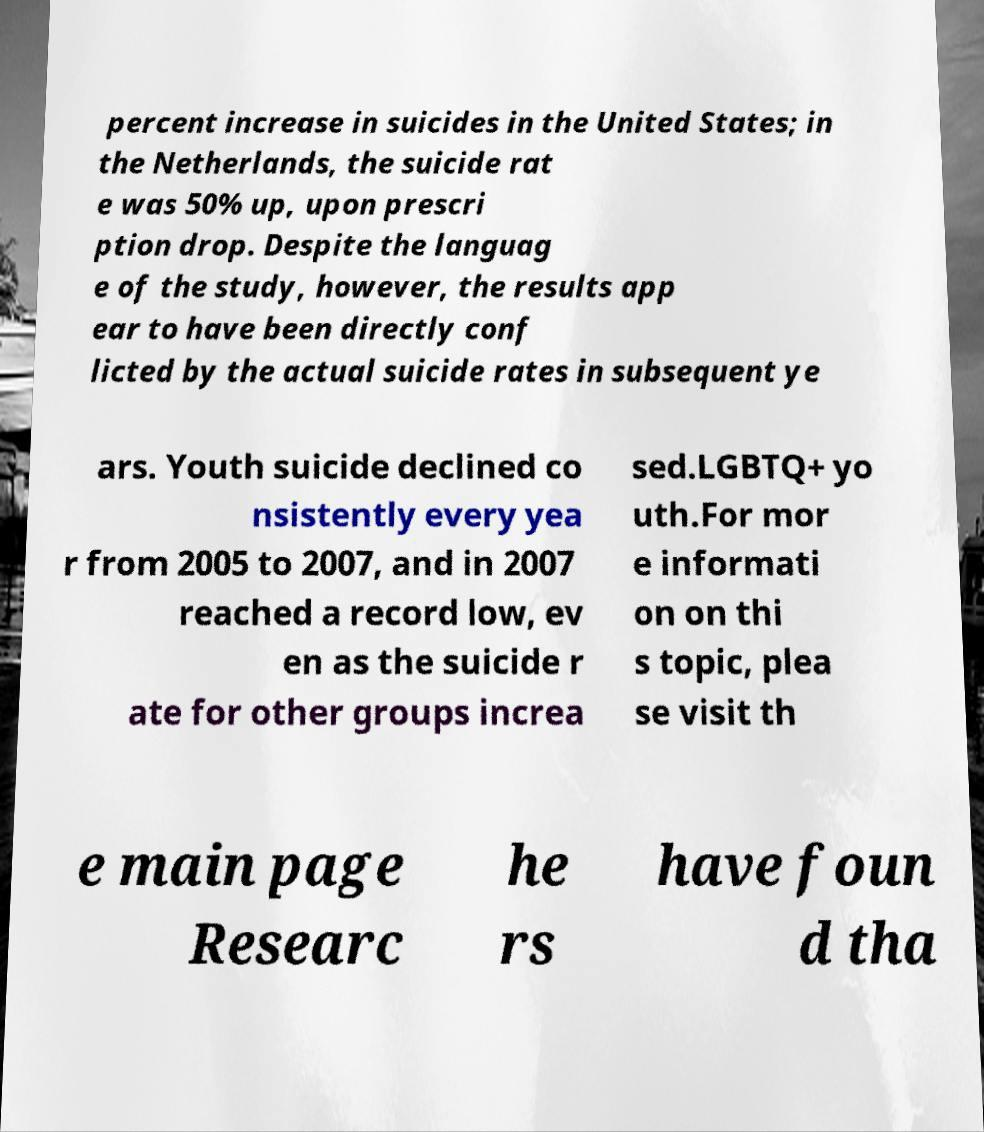Could you extract and type out the text from this image? percent increase in suicides in the United States; in the Netherlands, the suicide rat e was 50% up, upon prescri ption drop. Despite the languag e of the study, however, the results app ear to have been directly conf licted by the actual suicide rates in subsequent ye ars. Youth suicide declined co nsistently every yea r from 2005 to 2007, and in 2007 reached a record low, ev en as the suicide r ate for other groups increa sed.LGBTQ+ yo uth.For mor e informati on on thi s topic, plea se visit th e main page Researc he rs have foun d tha 